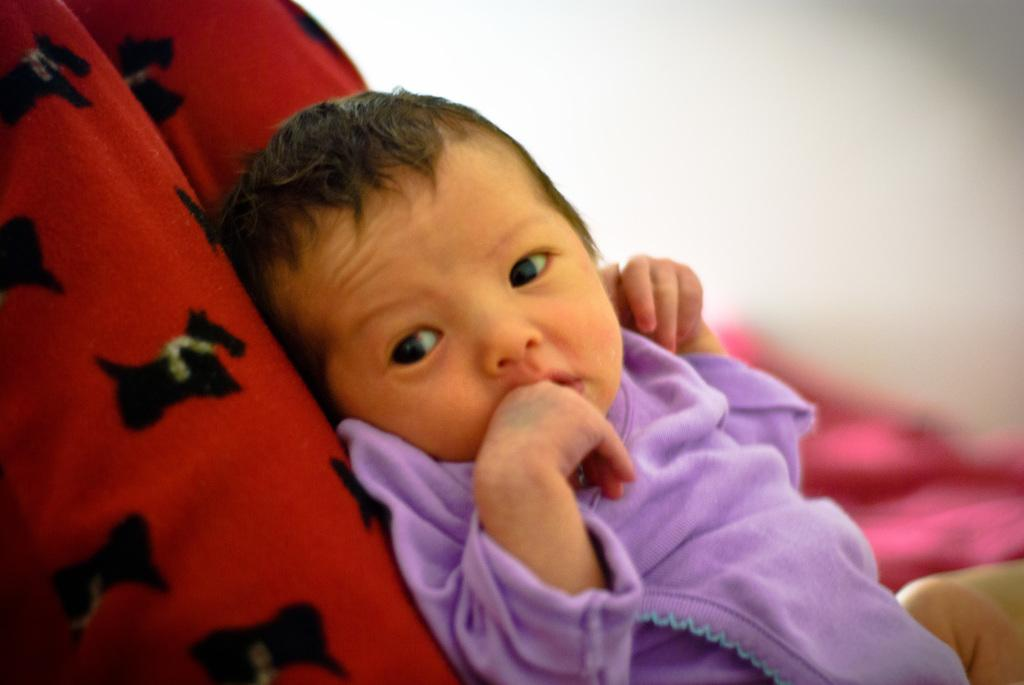What is the main subject of the image? There is a baby in the center of the image. What is the baby lying on? The baby is lying on an object. Can you describe the color of the object? The object has a red and black color. How would you describe the background of the image? The background of the image is blurred. What type of fruit is being held by the baby in the image? There is no fruit visible in the image; the baby is lying on an object with a red and black color. Is there a straw being used by the baby in the image? There is no straw present in the image. 